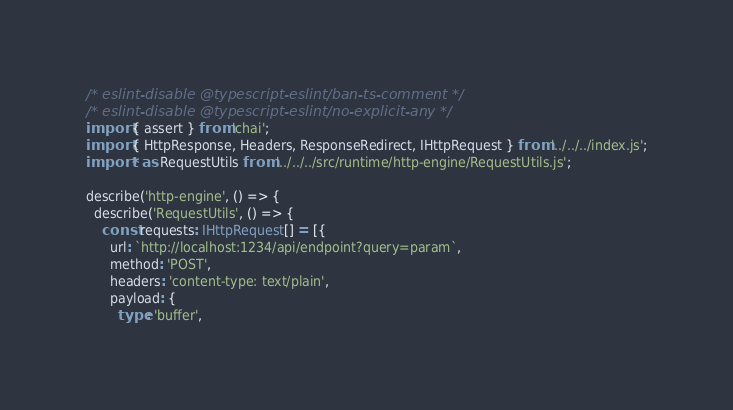Convert code to text. <code><loc_0><loc_0><loc_500><loc_500><_TypeScript_>/* eslint-disable @typescript-eslint/ban-ts-comment */
/* eslint-disable @typescript-eslint/no-explicit-any */
import { assert } from 'chai';
import { HttpResponse, Headers, ResponseRedirect, IHttpRequest } from '../../../index.js';
import * as RequestUtils from '../../../src/runtime/http-engine/RequestUtils.js';

describe('http-engine', () => {
  describe('RequestUtils', () => {
    const requests: IHttpRequest[] = [{
      url: `http://localhost:1234/api/endpoint?query=param`,
      method: 'POST',
      headers: 'content-type: text/plain',
      payload: {
        type: 'buffer',</code> 